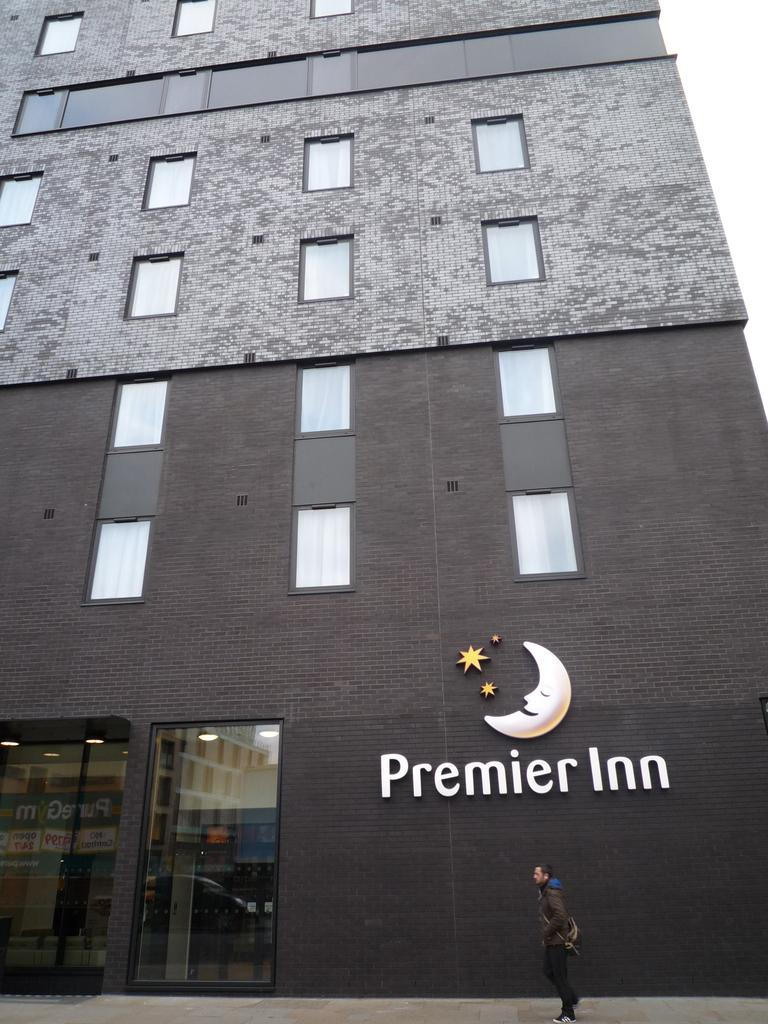<image>
Describe the image concisely. The outside of the Premier Inn with a half moon logo. 